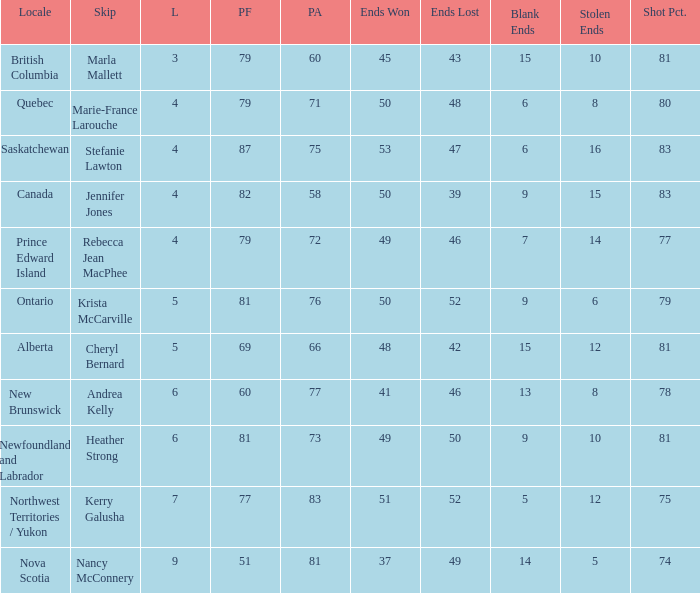Where was the 78% shot percentage located? New Brunswick. 